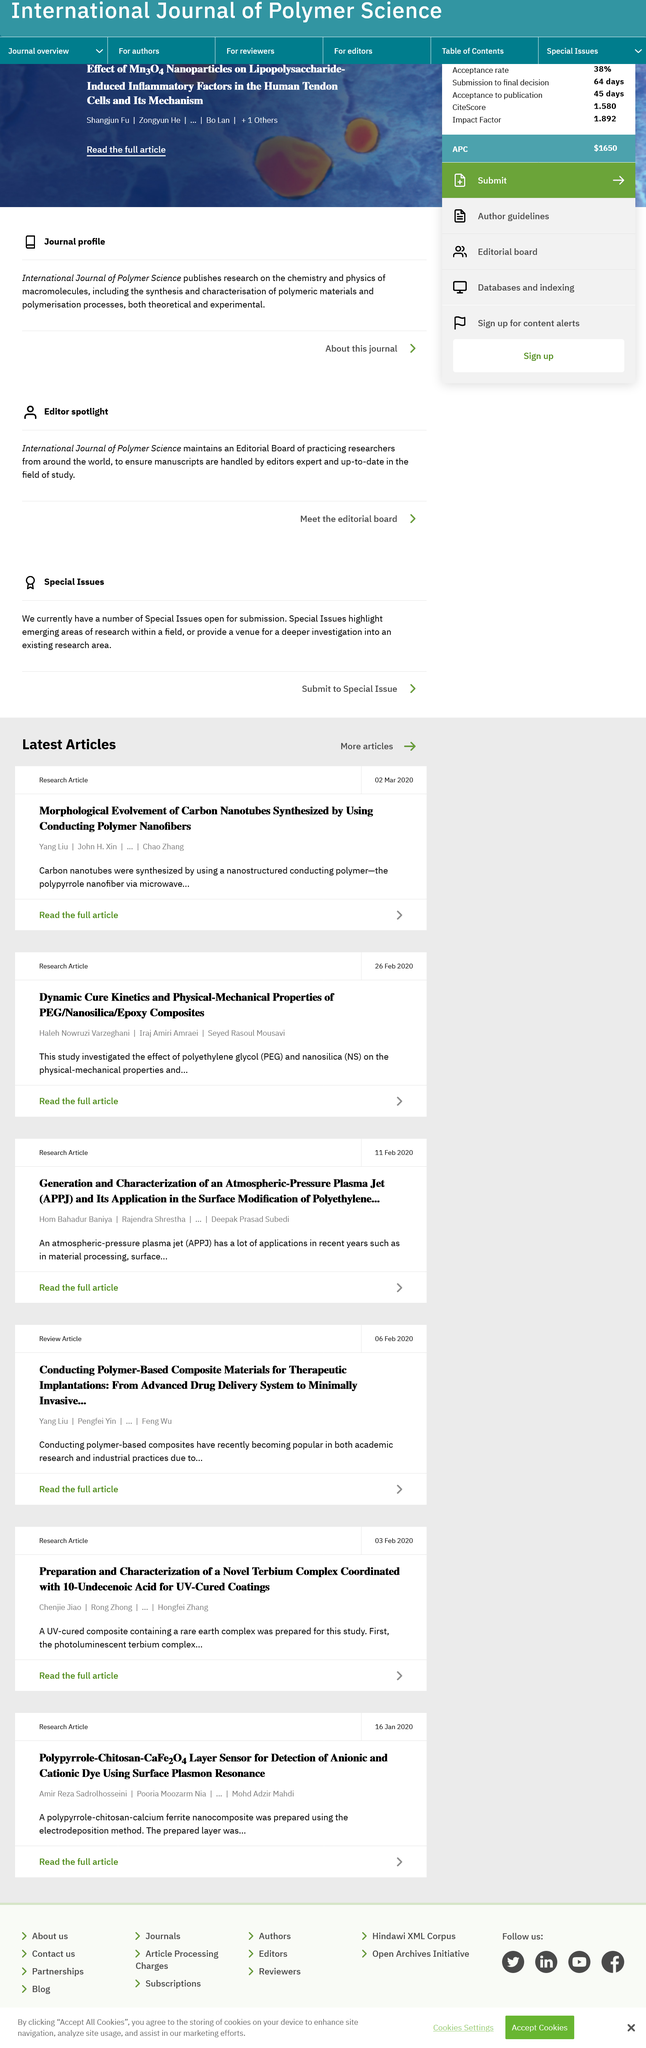Give some essential details in this illustration. The acronym "PEG" in this article refers to "Polyethylene glycol. On February 26, 2020, an article titled "Dynamic cure kinetics and physical-mechanical properties of PEG/Nanosilica/Epoxy composites" was published. The article "Dynamic cure kinetics and physical-mechanical properties of PEG/Nanosilica/Epoxy composites" was written by Haleh Nowruzi Varzeghani, Iraj Amiri Amraei and Seyed Rasoul Mousavi. 